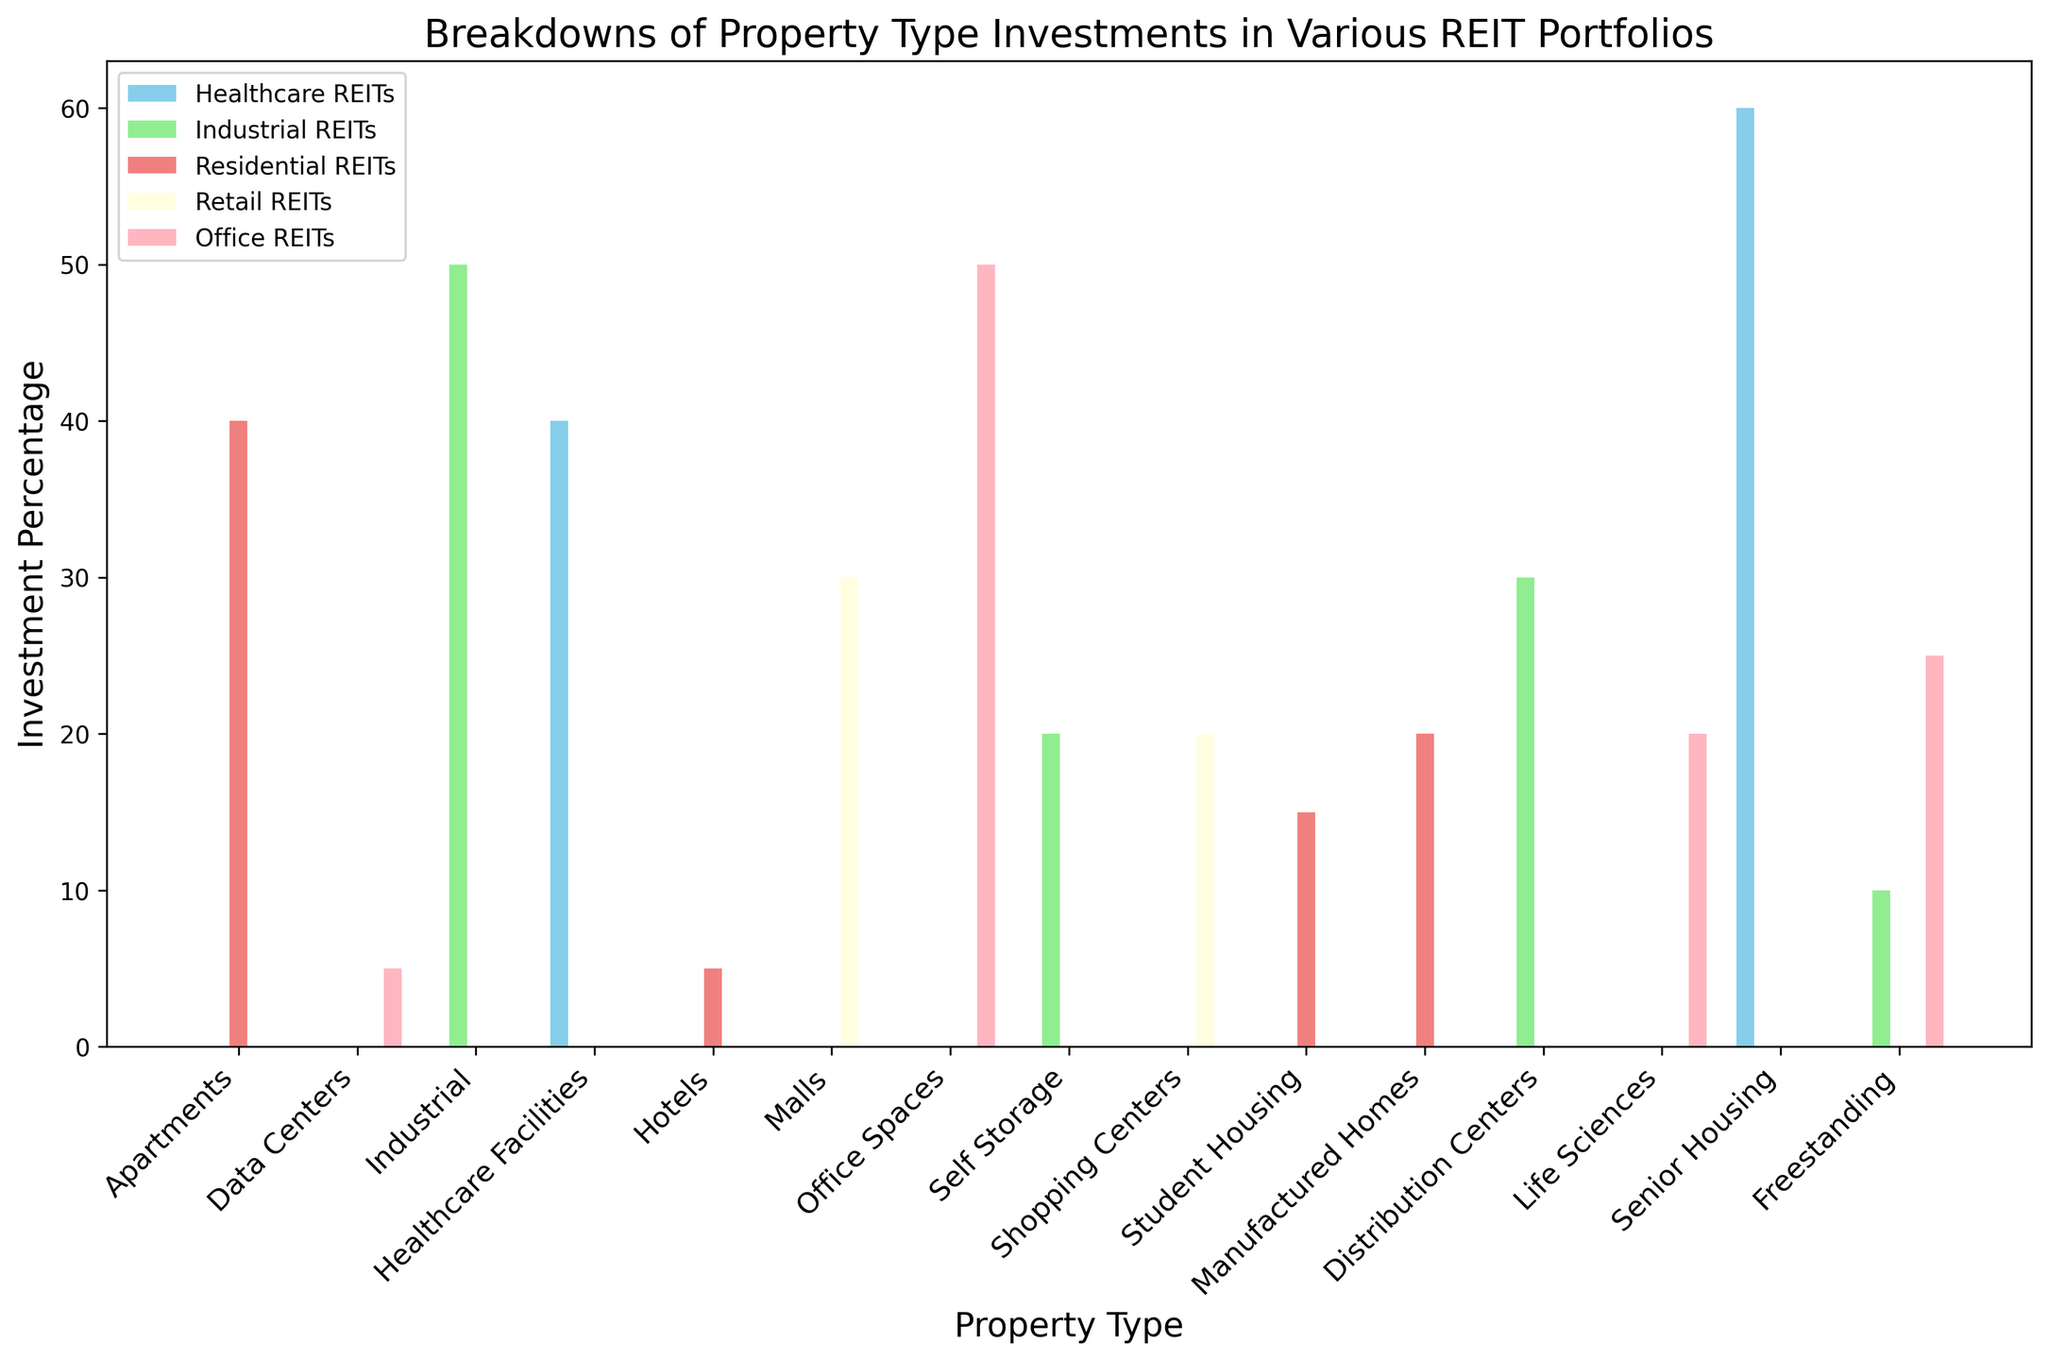What percentage of Residential REITs' investments are in Apartments? Locate the "Residential REITs" bar corresponding to "Apartments" and read the value. The value represents the investment percentage.
Answer: 40 Is there any REIT that invests in Healthcare Facilities? If so, what percentage? Check if there is a bar in the "Healthcare Facilities" category for any REIT and identify its height. The "Healthcare REITs" bar has a non-zero height in this category.
Answer: 40 Which property type has the highest investment percentage for Office REITs? Examine the heights of all the bars for "Office REITs" and identify the tallest one. The tallest bar corresponds to "Office Spaces."
Answer: Office Spaces How does the investment in Senior Housing compare between Residential REITs and Healthcare REITs? Compare the heights of the bars for "Senior Housing" in both "Residential REITs" and "Healthcare REITs." There is no bar for "Senior Housing" in "Residential REITs," but there is a substantial bar for "Healthcare REITs."
Answer: Healthcare REITs invest in Senior Housing; Residential REITs do not Which REIT has the most diversified investment across different property types, and what reasoning supports this? Count the number of different property types each REIT invests in by finding non-zero bars across the categories. The "Industrial REITs" category has investments in the most property types (4), namely Industrial, Self Storage, Distribution Centers, and Freestanding.
Answer: Industrial REITs How does the investment in Freestanding properties for Office REITs compare to that for Industrial REITs? Look at the heights of the bars for "Freestanding" in both "Office REITs" and "Industrial REITs." The height of the "Office REITs" bar is higher than that of the "Industrial REITs."
Answer: Office REITs invest more in Freestanding properties What is the combined investment percentage in Data Centers and Life Sciences for Office REITs? Add the heights of the bars for "Data Centers" and "Life Sciences" under "Office REITs." The values are 5% for "Data Centers" and 20% for "Life Sciences." Add these two figures together.
Answer: 25 Which REIT type invests the least in Self Storage, and what is the percentage? Identify the bars for "Self Storage" across all REIT types and find the smallest non-zero height. The "Office REITs," "Residential REITs," "Retail REITs," and "Healthcare REITs" do not invest in "Self Storage." The smallest non-zero investment in "Self Storage" is by "Industrial REITs."
Answer: Industrial REITs, 20 